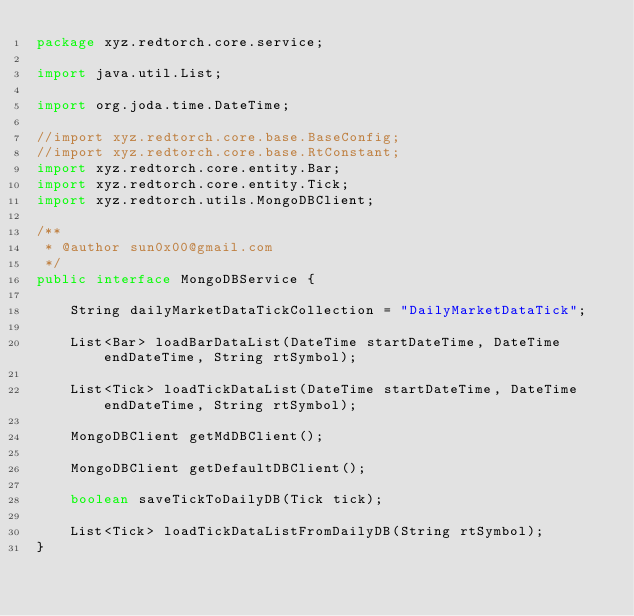Convert code to text. <code><loc_0><loc_0><loc_500><loc_500><_Java_>package xyz.redtorch.core.service;

import java.util.List;

import org.joda.time.DateTime;

//import xyz.redtorch.core.base.BaseConfig;
//import xyz.redtorch.core.base.RtConstant;
import xyz.redtorch.core.entity.Bar;
import xyz.redtorch.core.entity.Tick;
import xyz.redtorch.utils.MongoDBClient;

/**
 * @author sun0x00@gmail.com
 */
public interface MongoDBService {

	String dailyMarketDataTickCollection = "DailyMarketDataTick";

	List<Bar> loadBarDataList(DateTime startDateTime, DateTime endDateTime, String rtSymbol);

	List<Tick> loadTickDataList(DateTime startDateTime, DateTime endDateTime, String rtSymbol);
	
	MongoDBClient getMdDBClient();

	MongoDBClient getDefaultDBClient();

	boolean saveTickToDailyDB(Tick tick);
	
	List<Tick> loadTickDataListFromDailyDB(String rtSymbol);
}
</code> 